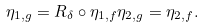<formula> <loc_0><loc_0><loc_500><loc_500>\eta _ { 1 , g } = R _ { \delta } \circ \eta _ { 1 , { f } } \eta _ { 2 , { g } } = \eta _ { 2 , { f } } .</formula> 